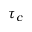<formula> <loc_0><loc_0><loc_500><loc_500>\tau _ { c }</formula> 